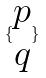Convert formula to latex. <formula><loc_0><loc_0><loc_500><loc_500>\{ \begin{matrix} p \\ q \end{matrix} \}</formula> 